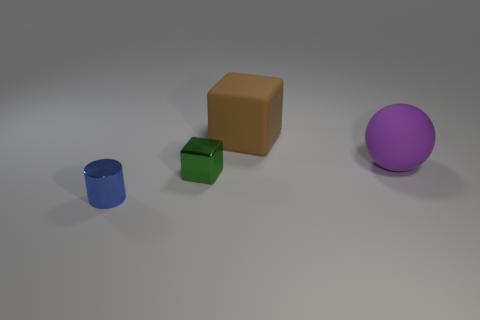Does the block that is in front of the brown thing have the same size as the tiny blue metal cylinder?
Keep it short and to the point. Yes. Are there more purple rubber things that are to the right of the large brown cube than small cylinders that are left of the blue shiny thing?
Your answer should be very brief. Yes. What color is the rubber thing that is on the right side of the cube that is behind the metallic thing that is on the right side of the blue cylinder?
Ensure brevity in your answer.  Purple. What number of other things are the same color as the cylinder?
Provide a succinct answer. 0. What number of objects are tiny blue shiny cylinders or large gray metallic balls?
Keep it short and to the point. 1. What number of objects are shiny cubes or metal things behind the tiny blue thing?
Ensure brevity in your answer.  1. Does the small block have the same material as the brown object?
Provide a short and direct response. No. How many other objects are there of the same material as the large brown object?
Give a very brief answer. 1. Is the number of green shiny things greater than the number of small gray matte balls?
Your answer should be compact. Yes. Do the green thing that is left of the brown matte cube and the blue object have the same shape?
Keep it short and to the point. No. 